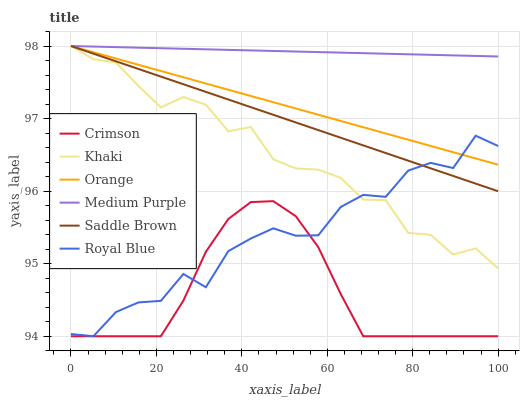Does Royal Blue have the minimum area under the curve?
Answer yes or no. No. Does Royal Blue have the maximum area under the curve?
Answer yes or no. No. Is Medium Purple the smoothest?
Answer yes or no. No. Is Medium Purple the roughest?
Answer yes or no. No. Does Medium Purple have the lowest value?
Answer yes or no. No. Does Royal Blue have the highest value?
Answer yes or no. No. Is Crimson less than Medium Purple?
Answer yes or no. Yes. Is Orange greater than Crimson?
Answer yes or no. Yes. Does Crimson intersect Medium Purple?
Answer yes or no. No. 